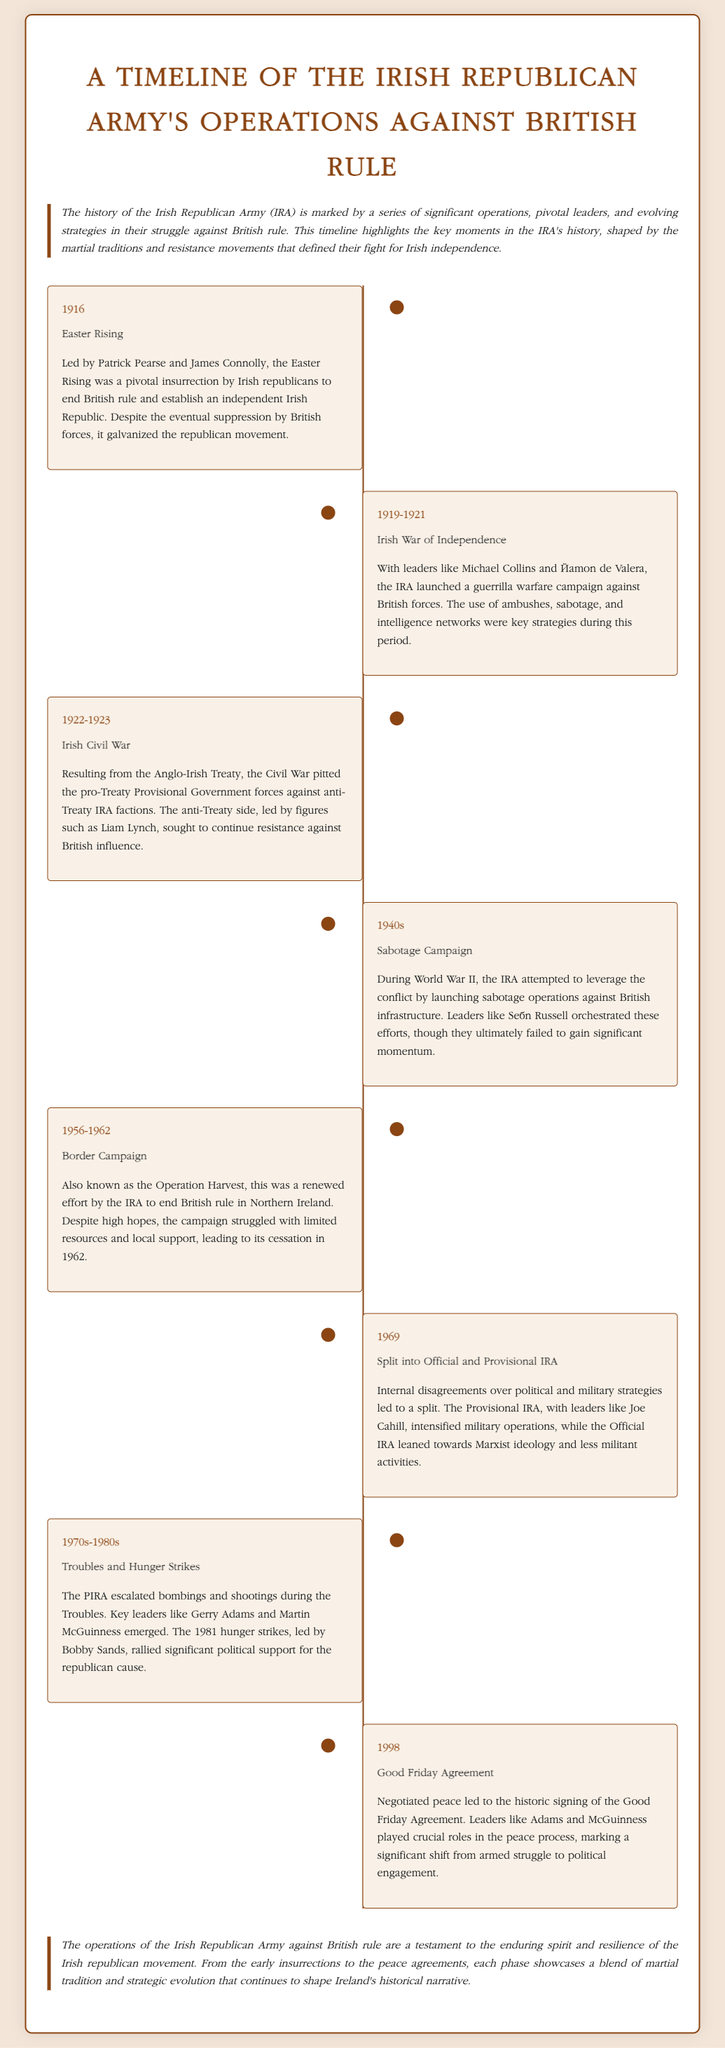What year did the Easter Rising occur? The event title and date correspond to the Easter Rising, which took place in 1916.
Answer: 1916 Who was a leader during the Irish War of Independence? The document mentions Michael Collins and Éamon de Valera as leaders during this pivotal period.
Answer: Michael Collins What operation did the IRA attempt during World War II? The document states that the IRA launched sabotage operations against British infrastructure during the 1940s.
Answer: Sabotage Campaign What was the name of the 1981 hunger strike leader? The document specifically identifies Bobby Sands as the leader of the hunger strikes in 1981.
Answer: Bobby Sands Which event led to the split into Official and Provisional IRA? The split occurred as a result of internal disagreements over political and military strategies in 1969.
Answer: 1969 What agreement marked a shift from armed struggle to political engagement? The Good Friday Agreement is noted in the document as the crucial event marking this shift.
Answer: Good Friday Agreement What campaign was known as Operation Harvest? The document describes the Border Campaign, which was referred to as Operation Harvest from 1956 to 1962.
Answer: Border Campaign Who led the anti-Treaty IRA factions during the Irish Civil War? The document states that Liam Lynch was a key leader of the anti-Treaty side in the Civil War from 1922 to 1923.
Answer: Liam Lynch What was the outcome of the Good Friday Agreement in 1998? This agreement paved the way for peace negotiations, marking a significant historical shift.
Answer: Peace negotiation 